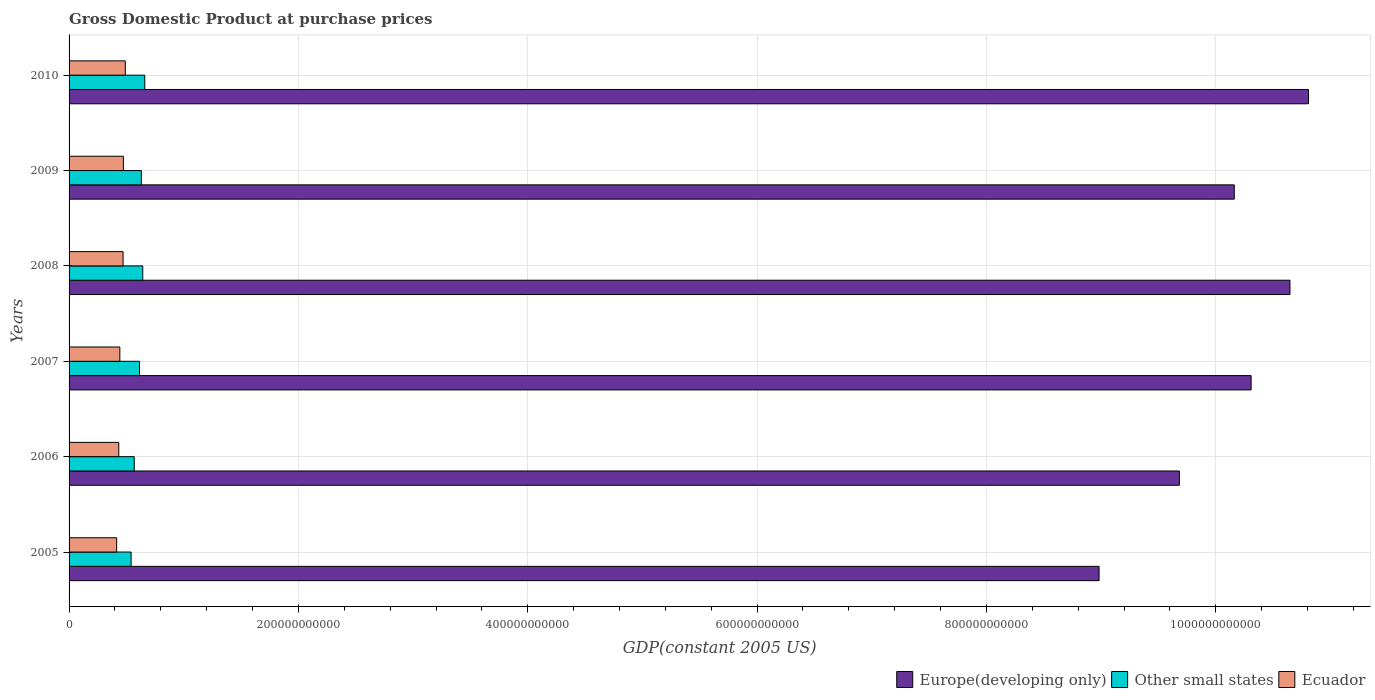How many groups of bars are there?
Your answer should be compact. 6. How many bars are there on the 4th tick from the top?
Keep it short and to the point. 3. How many bars are there on the 1st tick from the bottom?
Ensure brevity in your answer.  3. What is the label of the 2nd group of bars from the top?
Provide a succinct answer. 2009. What is the GDP at purchase prices in Other small states in 2010?
Make the answer very short. 6.60e+1. Across all years, what is the maximum GDP at purchase prices in Other small states?
Provide a short and direct response. 6.60e+1. Across all years, what is the minimum GDP at purchase prices in Other small states?
Your answer should be compact. 5.41e+1. What is the total GDP at purchase prices in Europe(developing only) in the graph?
Your answer should be compact. 6.06e+12. What is the difference between the GDP at purchase prices in Other small states in 2009 and that in 2010?
Your response must be concise. -3.00e+09. What is the difference between the GDP at purchase prices in Europe(developing only) in 2006 and the GDP at purchase prices in Other small states in 2007?
Your response must be concise. 9.07e+11. What is the average GDP at purchase prices in Ecuador per year?
Offer a very short reply. 4.54e+1. In the year 2010, what is the difference between the GDP at purchase prices in Other small states and GDP at purchase prices in Ecuador?
Offer a terse response. 1.70e+1. What is the ratio of the GDP at purchase prices in Europe(developing only) in 2007 to that in 2009?
Give a very brief answer. 1.01. Is the difference between the GDP at purchase prices in Other small states in 2007 and 2008 greater than the difference between the GDP at purchase prices in Ecuador in 2007 and 2008?
Provide a succinct answer. No. What is the difference between the highest and the second highest GDP at purchase prices in Europe(developing only)?
Keep it short and to the point. 1.62e+1. What is the difference between the highest and the lowest GDP at purchase prices in Europe(developing only)?
Provide a succinct answer. 1.83e+11. What does the 3rd bar from the top in 2006 represents?
Offer a terse response. Europe(developing only). What does the 2nd bar from the bottom in 2006 represents?
Provide a short and direct response. Other small states. Is it the case that in every year, the sum of the GDP at purchase prices in Europe(developing only) and GDP at purchase prices in Ecuador is greater than the GDP at purchase prices in Other small states?
Ensure brevity in your answer.  Yes. How many bars are there?
Provide a short and direct response. 18. Are all the bars in the graph horizontal?
Provide a short and direct response. Yes. How many years are there in the graph?
Give a very brief answer. 6. What is the difference between two consecutive major ticks on the X-axis?
Provide a succinct answer. 2.00e+11. Are the values on the major ticks of X-axis written in scientific E-notation?
Provide a short and direct response. No. Does the graph contain grids?
Your answer should be very brief. Yes. How many legend labels are there?
Give a very brief answer. 3. What is the title of the graph?
Make the answer very short. Gross Domestic Product at purchase prices. What is the label or title of the X-axis?
Offer a terse response. GDP(constant 2005 US). What is the label or title of the Y-axis?
Your answer should be very brief. Years. What is the GDP(constant 2005 US) in Europe(developing only) in 2005?
Your answer should be very brief. 8.98e+11. What is the GDP(constant 2005 US) in Other small states in 2005?
Your answer should be compact. 5.41e+1. What is the GDP(constant 2005 US) of Ecuador in 2005?
Give a very brief answer. 4.15e+1. What is the GDP(constant 2005 US) in Europe(developing only) in 2006?
Your response must be concise. 9.68e+11. What is the GDP(constant 2005 US) of Other small states in 2006?
Provide a succinct answer. 5.68e+1. What is the GDP(constant 2005 US) of Ecuador in 2006?
Offer a terse response. 4.33e+1. What is the GDP(constant 2005 US) in Europe(developing only) in 2007?
Offer a very short reply. 1.03e+12. What is the GDP(constant 2005 US) in Other small states in 2007?
Provide a short and direct response. 6.14e+1. What is the GDP(constant 2005 US) in Ecuador in 2007?
Keep it short and to the point. 4.43e+1. What is the GDP(constant 2005 US) of Europe(developing only) in 2008?
Make the answer very short. 1.06e+12. What is the GDP(constant 2005 US) of Other small states in 2008?
Your answer should be compact. 6.43e+1. What is the GDP(constant 2005 US) in Ecuador in 2008?
Your answer should be very brief. 4.71e+1. What is the GDP(constant 2005 US) in Europe(developing only) in 2009?
Offer a very short reply. 1.02e+12. What is the GDP(constant 2005 US) of Other small states in 2009?
Ensure brevity in your answer.  6.30e+1. What is the GDP(constant 2005 US) of Ecuador in 2009?
Ensure brevity in your answer.  4.74e+1. What is the GDP(constant 2005 US) in Europe(developing only) in 2010?
Provide a short and direct response. 1.08e+12. What is the GDP(constant 2005 US) of Other small states in 2010?
Your answer should be very brief. 6.60e+1. What is the GDP(constant 2005 US) in Ecuador in 2010?
Give a very brief answer. 4.90e+1. Across all years, what is the maximum GDP(constant 2005 US) of Europe(developing only)?
Offer a very short reply. 1.08e+12. Across all years, what is the maximum GDP(constant 2005 US) of Other small states?
Offer a terse response. 6.60e+1. Across all years, what is the maximum GDP(constant 2005 US) of Ecuador?
Your answer should be very brief. 4.90e+1. Across all years, what is the minimum GDP(constant 2005 US) of Europe(developing only)?
Your response must be concise. 8.98e+11. Across all years, what is the minimum GDP(constant 2005 US) of Other small states?
Your response must be concise. 5.41e+1. Across all years, what is the minimum GDP(constant 2005 US) in Ecuador?
Provide a short and direct response. 4.15e+1. What is the total GDP(constant 2005 US) in Europe(developing only) in the graph?
Provide a succinct answer. 6.06e+12. What is the total GDP(constant 2005 US) of Other small states in the graph?
Your response must be concise. 3.66e+11. What is the total GDP(constant 2005 US) of Ecuador in the graph?
Ensure brevity in your answer.  2.73e+11. What is the difference between the GDP(constant 2005 US) of Europe(developing only) in 2005 and that in 2006?
Make the answer very short. -7.00e+1. What is the difference between the GDP(constant 2005 US) of Other small states in 2005 and that in 2006?
Provide a short and direct response. -2.72e+09. What is the difference between the GDP(constant 2005 US) in Ecuador in 2005 and that in 2006?
Offer a terse response. -1.83e+09. What is the difference between the GDP(constant 2005 US) in Europe(developing only) in 2005 and that in 2007?
Give a very brief answer. -1.33e+11. What is the difference between the GDP(constant 2005 US) in Other small states in 2005 and that in 2007?
Your answer should be compact. -7.31e+09. What is the difference between the GDP(constant 2005 US) in Ecuador in 2005 and that in 2007?
Offer a terse response. -2.78e+09. What is the difference between the GDP(constant 2005 US) in Europe(developing only) in 2005 and that in 2008?
Your response must be concise. -1.66e+11. What is the difference between the GDP(constant 2005 US) of Other small states in 2005 and that in 2008?
Your answer should be compact. -1.02e+1. What is the difference between the GDP(constant 2005 US) of Ecuador in 2005 and that in 2008?
Make the answer very short. -5.59e+09. What is the difference between the GDP(constant 2005 US) in Europe(developing only) in 2005 and that in 2009?
Your answer should be compact. -1.18e+11. What is the difference between the GDP(constant 2005 US) of Other small states in 2005 and that in 2009?
Give a very brief answer. -8.92e+09. What is the difference between the GDP(constant 2005 US) in Ecuador in 2005 and that in 2009?
Your response must be concise. -5.86e+09. What is the difference between the GDP(constant 2005 US) of Europe(developing only) in 2005 and that in 2010?
Your answer should be very brief. -1.83e+11. What is the difference between the GDP(constant 2005 US) of Other small states in 2005 and that in 2010?
Your answer should be very brief. -1.19e+1. What is the difference between the GDP(constant 2005 US) of Ecuador in 2005 and that in 2010?
Your answer should be very brief. -7.53e+09. What is the difference between the GDP(constant 2005 US) of Europe(developing only) in 2006 and that in 2007?
Offer a very short reply. -6.26e+1. What is the difference between the GDP(constant 2005 US) of Other small states in 2006 and that in 2007?
Keep it short and to the point. -4.60e+09. What is the difference between the GDP(constant 2005 US) of Ecuador in 2006 and that in 2007?
Your response must be concise. -9.49e+08. What is the difference between the GDP(constant 2005 US) in Europe(developing only) in 2006 and that in 2008?
Your answer should be very brief. -9.64e+1. What is the difference between the GDP(constant 2005 US) of Other small states in 2006 and that in 2008?
Ensure brevity in your answer.  -7.43e+09. What is the difference between the GDP(constant 2005 US) of Ecuador in 2006 and that in 2008?
Provide a short and direct response. -3.76e+09. What is the difference between the GDP(constant 2005 US) of Europe(developing only) in 2006 and that in 2009?
Offer a terse response. -4.79e+1. What is the difference between the GDP(constant 2005 US) of Other small states in 2006 and that in 2009?
Offer a very short reply. -6.20e+09. What is the difference between the GDP(constant 2005 US) in Ecuador in 2006 and that in 2009?
Your response must be concise. -4.03e+09. What is the difference between the GDP(constant 2005 US) in Europe(developing only) in 2006 and that in 2010?
Provide a succinct answer. -1.13e+11. What is the difference between the GDP(constant 2005 US) in Other small states in 2006 and that in 2010?
Provide a short and direct response. -9.20e+09. What is the difference between the GDP(constant 2005 US) of Ecuador in 2006 and that in 2010?
Make the answer very short. -5.70e+09. What is the difference between the GDP(constant 2005 US) of Europe(developing only) in 2007 and that in 2008?
Provide a short and direct response. -3.39e+1. What is the difference between the GDP(constant 2005 US) of Other small states in 2007 and that in 2008?
Keep it short and to the point. -2.84e+09. What is the difference between the GDP(constant 2005 US) in Ecuador in 2007 and that in 2008?
Give a very brief answer. -2.82e+09. What is the difference between the GDP(constant 2005 US) of Europe(developing only) in 2007 and that in 2009?
Ensure brevity in your answer.  1.47e+1. What is the difference between the GDP(constant 2005 US) of Other small states in 2007 and that in 2009?
Offer a terse response. -1.60e+09. What is the difference between the GDP(constant 2005 US) in Ecuador in 2007 and that in 2009?
Your response must be concise. -3.08e+09. What is the difference between the GDP(constant 2005 US) in Europe(developing only) in 2007 and that in 2010?
Provide a short and direct response. -5.01e+1. What is the difference between the GDP(constant 2005 US) in Other small states in 2007 and that in 2010?
Offer a terse response. -4.60e+09. What is the difference between the GDP(constant 2005 US) of Ecuador in 2007 and that in 2010?
Keep it short and to the point. -4.75e+09. What is the difference between the GDP(constant 2005 US) of Europe(developing only) in 2008 and that in 2009?
Provide a succinct answer. 4.86e+1. What is the difference between the GDP(constant 2005 US) of Other small states in 2008 and that in 2009?
Ensure brevity in your answer.  1.23e+09. What is the difference between the GDP(constant 2005 US) in Ecuador in 2008 and that in 2009?
Provide a succinct answer. -2.67e+08. What is the difference between the GDP(constant 2005 US) of Europe(developing only) in 2008 and that in 2010?
Give a very brief answer. -1.62e+1. What is the difference between the GDP(constant 2005 US) in Other small states in 2008 and that in 2010?
Offer a terse response. -1.76e+09. What is the difference between the GDP(constant 2005 US) in Ecuador in 2008 and that in 2010?
Offer a very short reply. -1.94e+09. What is the difference between the GDP(constant 2005 US) in Europe(developing only) in 2009 and that in 2010?
Your response must be concise. -6.47e+1. What is the difference between the GDP(constant 2005 US) of Other small states in 2009 and that in 2010?
Your answer should be very brief. -3.00e+09. What is the difference between the GDP(constant 2005 US) in Ecuador in 2009 and that in 2010?
Make the answer very short. -1.67e+09. What is the difference between the GDP(constant 2005 US) in Europe(developing only) in 2005 and the GDP(constant 2005 US) in Other small states in 2006?
Give a very brief answer. 8.41e+11. What is the difference between the GDP(constant 2005 US) of Europe(developing only) in 2005 and the GDP(constant 2005 US) of Ecuador in 2006?
Give a very brief answer. 8.55e+11. What is the difference between the GDP(constant 2005 US) in Other small states in 2005 and the GDP(constant 2005 US) in Ecuador in 2006?
Give a very brief answer. 1.08e+1. What is the difference between the GDP(constant 2005 US) in Europe(developing only) in 2005 and the GDP(constant 2005 US) in Other small states in 2007?
Provide a short and direct response. 8.37e+11. What is the difference between the GDP(constant 2005 US) of Europe(developing only) in 2005 and the GDP(constant 2005 US) of Ecuador in 2007?
Provide a succinct answer. 8.54e+11. What is the difference between the GDP(constant 2005 US) of Other small states in 2005 and the GDP(constant 2005 US) of Ecuador in 2007?
Your answer should be very brief. 9.83e+09. What is the difference between the GDP(constant 2005 US) in Europe(developing only) in 2005 and the GDP(constant 2005 US) in Other small states in 2008?
Your answer should be compact. 8.34e+11. What is the difference between the GDP(constant 2005 US) in Europe(developing only) in 2005 and the GDP(constant 2005 US) in Ecuador in 2008?
Make the answer very short. 8.51e+11. What is the difference between the GDP(constant 2005 US) of Other small states in 2005 and the GDP(constant 2005 US) of Ecuador in 2008?
Offer a terse response. 7.01e+09. What is the difference between the GDP(constant 2005 US) in Europe(developing only) in 2005 and the GDP(constant 2005 US) in Other small states in 2009?
Your answer should be very brief. 8.35e+11. What is the difference between the GDP(constant 2005 US) of Europe(developing only) in 2005 and the GDP(constant 2005 US) of Ecuador in 2009?
Offer a very short reply. 8.51e+11. What is the difference between the GDP(constant 2005 US) of Other small states in 2005 and the GDP(constant 2005 US) of Ecuador in 2009?
Your answer should be very brief. 6.74e+09. What is the difference between the GDP(constant 2005 US) in Europe(developing only) in 2005 and the GDP(constant 2005 US) in Other small states in 2010?
Offer a terse response. 8.32e+11. What is the difference between the GDP(constant 2005 US) in Europe(developing only) in 2005 and the GDP(constant 2005 US) in Ecuador in 2010?
Your answer should be compact. 8.49e+11. What is the difference between the GDP(constant 2005 US) in Other small states in 2005 and the GDP(constant 2005 US) in Ecuador in 2010?
Ensure brevity in your answer.  5.07e+09. What is the difference between the GDP(constant 2005 US) in Europe(developing only) in 2006 and the GDP(constant 2005 US) in Other small states in 2007?
Keep it short and to the point. 9.07e+11. What is the difference between the GDP(constant 2005 US) in Europe(developing only) in 2006 and the GDP(constant 2005 US) in Ecuador in 2007?
Ensure brevity in your answer.  9.24e+11. What is the difference between the GDP(constant 2005 US) of Other small states in 2006 and the GDP(constant 2005 US) of Ecuador in 2007?
Make the answer very short. 1.25e+1. What is the difference between the GDP(constant 2005 US) in Europe(developing only) in 2006 and the GDP(constant 2005 US) in Other small states in 2008?
Make the answer very short. 9.04e+11. What is the difference between the GDP(constant 2005 US) of Europe(developing only) in 2006 and the GDP(constant 2005 US) of Ecuador in 2008?
Your answer should be compact. 9.21e+11. What is the difference between the GDP(constant 2005 US) of Other small states in 2006 and the GDP(constant 2005 US) of Ecuador in 2008?
Offer a terse response. 9.73e+09. What is the difference between the GDP(constant 2005 US) in Europe(developing only) in 2006 and the GDP(constant 2005 US) in Other small states in 2009?
Give a very brief answer. 9.05e+11. What is the difference between the GDP(constant 2005 US) in Europe(developing only) in 2006 and the GDP(constant 2005 US) in Ecuador in 2009?
Provide a short and direct response. 9.21e+11. What is the difference between the GDP(constant 2005 US) in Other small states in 2006 and the GDP(constant 2005 US) in Ecuador in 2009?
Ensure brevity in your answer.  9.46e+09. What is the difference between the GDP(constant 2005 US) in Europe(developing only) in 2006 and the GDP(constant 2005 US) in Other small states in 2010?
Offer a terse response. 9.02e+11. What is the difference between the GDP(constant 2005 US) in Europe(developing only) in 2006 and the GDP(constant 2005 US) in Ecuador in 2010?
Ensure brevity in your answer.  9.19e+11. What is the difference between the GDP(constant 2005 US) of Other small states in 2006 and the GDP(constant 2005 US) of Ecuador in 2010?
Your answer should be compact. 7.79e+09. What is the difference between the GDP(constant 2005 US) in Europe(developing only) in 2007 and the GDP(constant 2005 US) in Other small states in 2008?
Offer a terse response. 9.67e+11. What is the difference between the GDP(constant 2005 US) in Europe(developing only) in 2007 and the GDP(constant 2005 US) in Ecuador in 2008?
Your response must be concise. 9.84e+11. What is the difference between the GDP(constant 2005 US) in Other small states in 2007 and the GDP(constant 2005 US) in Ecuador in 2008?
Keep it short and to the point. 1.43e+1. What is the difference between the GDP(constant 2005 US) in Europe(developing only) in 2007 and the GDP(constant 2005 US) in Other small states in 2009?
Your response must be concise. 9.68e+11. What is the difference between the GDP(constant 2005 US) of Europe(developing only) in 2007 and the GDP(constant 2005 US) of Ecuador in 2009?
Your answer should be compact. 9.83e+11. What is the difference between the GDP(constant 2005 US) in Other small states in 2007 and the GDP(constant 2005 US) in Ecuador in 2009?
Your answer should be compact. 1.41e+1. What is the difference between the GDP(constant 2005 US) of Europe(developing only) in 2007 and the GDP(constant 2005 US) of Other small states in 2010?
Keep it short and to the point. 9.65e+11. What is the difference between the GDP(constant 2005 US) of Europe(developing only) in 2007 and the GDP(constant 2005 US) of Ecuador in 2010?
Give a very brief answer. 9.82e+11. What is the difference between the GDP(constant 2005 US) of Other small states in 2007 and the GDP(constant 2005 US) of Ecuador in 2010?
Your answer should be compact. 1.24e+1. What is the difference between the GDP(constant 2005 US) in Europe(developing only) in 2008 and the GDP(constant 2005 US) in Other small states in 2009?
Ensure brevity in your answer.  1.00e+12. What is the difference between the GDP(constant 2005 US) in Europe(developing only) in 2008 and the GDP(constant 2005 US) in Ecuador in 2009?
Offer a terse response. 1.02e+12. What is the difference between the GDP(constant 2005 US) of Other small states in 2008 and the GDP(constant 2005 US) of Ecuador in 2009?
Your answer should be very brief. 1.69e+1. What is the difference between the GDP(constant 2005 US) in Europe(developing only) in 2008 and the GDP(constant 2005 US) in Other small states in 2010?
Keep it short and to the point. 9.99e+11. What is the difference between the GDP(constant 2005 US) in Europe(developing only) in 2008 and the GDP(constant 2005 US) in Ecuador in 2010?
Make the answer very short. 1.02e+12. What is the difference between the GDP(constant 2005 US) in Other small states in 2008 and the GDP(constant 2005 US) in Ecuador in 2010?
Your answer should be compact. 1.52e+1. What is the difference between the GDP(constant 2005 US) in Europe(developing only) in 2009 and the GDP(constant 2005 US) in Other small states in 2010?
Offer a very short reply. 9.50e+11. What is the difference between the GDP(constant 2005 US) of Europe(developing only) in 2009 and the GDP(constant 2005 US) of Ecuador in 2010?
Offer a very short reply. 9.67e+11. What is the difference between the GDP(constant 2005 US) of Other small states in 2009 and the GDP(constant 2005 US) of Ecuador in 2010?
Provide a succinct answer. 1.40e+1. What is the average GDP(constant 2005 US) of Europe(developing only) per year?
Provide a succinct answer. 1.01e+12. What is the average GDP(constant 2005 US) of Other small states per year?
Provide a succinct answer. 6.09e+1. What is the average GDP(constant 2005 US) in Ecuador per year?
Give a very brief answer. 4.54e+1. In the year 2005, what is the difference between the GDP(constant 2005 US) of Europe(developing only) and GDP(constant 2005 US) of Other small states?
Your answer should be very brief. 8.44e+11. In the year 2005, what is the difference between the GDP(constant 2005 US) in Europe(developing only) and GDP(constant 2005 US) in Ecuador?
Your response must be concise. 8.57e+11. In the year 2005, what is the difference between the GDP(constant 2005 US) in Other small states and GDP(constant 2005 US) in Ecuador?
Offer a very short reply. 1.26e+1. In the year 2006, what is the difference between the GDP(constant 2005 US) of Europe(developing only) and GDP(constant 2005 US) of Other small states?
Give a very brief answer. 9.11e+11. In the year 2006, what is the difference between the GDP(constant 2005 US) of Europe(developing only) and GDP(constant 2005 US) of Ecuador?
Make the answer very short. 9.25e+11. In the year 2006, what is the difference between the GDP(constant 2005 US) in Other small states and GDP(constant 2005 US) in Ecuador?
Make the answer very short. 1.35e+1. In the year 2007, what is the difference between the GDP(constant 2005 US) in Europe(developing only) and GDP(constant 2005 US) in Other small states?
Ensure brevity in your answer.  9.69e+11. In the year 2007, what is the difference between the GDP(constant 2005 US) in Europe(developing only) and GDP(constant 2005 US) in Ecuador?
Provide a short and direct response. 9.87e+11. In the year 2007, what is the difference between the GDP(constant 2005 US) in Other small states and GDP(constant 2005 US) in Ecuador?
Provide a short and direct response. 1.71e+1. In the year 2008, what is the difference between the GDP(constant 2005 US) of Europe(developing only) and GDP(constant 2005 US) of Other small states?
Make the answer very short. 1.00e+12. In the year 2008, what is the difference between the GDP(constant 2005 US) in Europe(developing only) and GDP(constant 2005 US) in Ecuador?
Your response must be concise. 1.02e+12. In the year 2008, what is the difference between the GDP(constant 2005 US) of Other small states and GDP(constant 2005 US) of Ecuador?
Offer a terse response. 1.72e+1. In the year 2009, what is the difference between the GDP(constant 2005 US) in Europe(developing only) and GDP(constant 2005 US) in Other small states?
Your answer should be compact. 9.53e+11. In the year 2009, what is the difference between the GDP(constant 2005 US) of Europe(developing only) and GDP(constant 2005 US) of Ecuador?
Provide a succinct answer. 9.69e+11. In the year 2009, what is the difference between the GDP(constant 2005 US) of Other small states and GDP(constant 2005 US) of Ecuador?
Ensure brevity in your answer.  1.57e+1. In the year 2010, what is the difference between the GDP(constant 2005 US) in Europe(developing only) and GDP(constant 2005 US) in Other small states?
Offer a terse response. 1.01e+12. In the year 2010, what is the difference between the GDP(constant 2005 US) of Europe(developing only) and GDP(constant 2005 US) of Ecuador?
Keep it short and to the point. 1.03e+12. In the year 2010, what is the difference between the GDP(constant 2005 US) in Other small states and GDP(constant 2005 US) in Ecuador?
Your response must be concise. 1.70e+1. What is the ratio of the GDP(constant 2005 US) of Europe(developing only) in 2005 to that in 2006?
Offer a terse response. 0.93. What is the ratio of the GDP(constant 2005 US) of Other small states in 2005 to that in 2006?
Give a very brief answer. 0.95. What is the ratio of the GDP(constant 2005 US) of Ecuador in 2005 to that in 2006?
Ensure brevity in your answer.  0.96. What is the ratio of the GDP(constant 2005 US) in Europe(developing only) in 2005 to that in 2007?
Give a very brief answer. 0.87. What is the ratio of the GDP(constant 2005 US) of Other small states in 2005 to that in 2007?
Make the answer very short. 0.88. What is the ratio of the GDP(constant 2005 US) of Ecuador in 2005 to that in 2007?
Make the answer very short. 0.94. What is the ratio of the GDP(constant 2005 US) in Europe(developing only) in 2005 to that in 2008?
Offer a terse response. 0.84. What is the ratio of the GDP(constant 2005 US) in Other small states in 2005 to that in 2008?
Keep it short and to the point. 0.84. What is the ratio of the GDP(constant 2005 US) in Ecuador in 2005 to that in 2008?
Ensure brevity in your answer.  0.88. What is the ratio of the GDP(constant 2005 US) in Europe(developing only) in 2005 to that in 2009?
Your response must be concise. 0.88. What is the ratio of the GDP(constant 2005 US) of Other small states in 2005 to that in 2009?
Give a very brief answer. 0.86. What is the ratio of the GDP(constant 2005 US) in Ecuador in 2005 to that in 2009?
Your response must be concise. 0.88. What is the ratio of the GDP(constant 2005 US) in Europe(developing only) in 2005 to that in 2010?
Make the answer very short. 0.83. What is the ratio of the GDP(constant 2005 US) in Other small states in 2005 to that in 2010?
Your answer should be compact. 0.82. What is the ratio of the GDP(constant 2005 US) in Ecuador in 2005 to that in 2010?
Your response must be concise. 0.85. What is the ratio of the GDP(constant 2005 US) in Europe(developing only) in 2006 to that in 2007?
Give a very brief answer. 0.94. What is the ratio of the GDP(constant 2005 US) in Other small states in 2006 to that in 2007?
Provide a succinct answer. 0.93. What is the ratio of the GDP(constant 2005 US) of Ecuador in 2006 to that in 2007?
Your answer should be compact. 0.98. What is the ratio of the GDP(constant 2005 US) of Europe(developing only) in 2006 to that in 2008?
Keep it short and to the point. 0.91. What is the ratio of the GDP(constant 2005 US) of Other small states in 2006 to that in 2008?
Provide a short and direct response. 0.88. What is the ratio of the GDP(constant 2005 US) in Ecuador in 2006 to that in 2008?
Your answer should be very brief. 0.92. What is the ratio of the GDP(constant 2005 US) of Europe(developing only) in 2006 to that in 2009?
Your answer should be compact. 0.95. What is the ratio of the GDP(constant 2005 US) in Other small states in 2006 to that in 2009?
Your response must be concise. 0.9. What is the ratio of the GDP(constant 2005 US) of Ecuador in 2006 to that in 2009?
Your answer should be compact. 0.91. What is the ratio of the GDP(constant 2005 US) in Europe(developing only) in 2006 to that in 2010?
Ensure brevity in your answer.  0.9. What is the ratio of the GDP(constant 2005 US) in Other small states in 2006 to that in 2010?
Your answer should be compact. 0.86. What is the ratio of the GDP(constant 2005 US) in Ecuador in 2006 to that in 2010?
Make the answer very short. 0.88. What is the ratio of the GDP(constant 2005 US) in Europe(developing only) in 2007 to that in 2008?
Give a very brief answer. 0.97. What is the ratio of the GDP(constant 2005 US) in Other small states in 2007 to that in 2008?
Keep it short and to the point. 0.96. What is the ratio of the GDP(constant 2005 US) in Ecuador in 2007 to that in 2008?
Your answer should be very brief. 0.94. What is the ratio of the GDP(constant 2005 US) in Europe(developing only) in 2007 to that in 2009?
Keep it short and to the point. 1.01. What is the ratio of the GDP(constant 2005 US) in Other small states in 2007 to that in 2009?
Provide a short and direct response. 0.97. What is the ratio of the GDP(constant 2005 US) in Ecuador in 2007 to that in 2009?
Offer a terse response. 0.93. What is the ratio of the GDP(constant 2005 US) in Europe(developing only) in 2007 to that in 2010?
Your answer should be compact. 0.95. What is the ratio of the GDP(constant 2005 US) of Other small states in 2007 to that in 2010?
Offer a terse response. 0.93. What is the ratio of the GDP(constant 2005 US) in Ecuador in 2007 to that in 2010?
Your answer should be compact. 0.9. What is the ratio of the GDP(constant 2005 US) in Europe(developing only) in 2008 to that in 2009?
Provide a short and direct response. 1.05. What is the ratio of the GDP(constant 2005 US) in Other small states in 2008 to that in 2009?
Give a very brief answer. 1.02. What is the ratio of the GDP(constant 2005 US) in Europe(developing only) in 2008 to that in 2010?
Offer a terse response. 0.98. What is the ratio of the GDP(constant 2005 US) of Other small states in 2008 to that in 2010?
Your answer should be very brief. 0.97. What is the ratio of the GDP(constant 2005 US) in Ecuador in 2008 to that in 2010?
Give a very brief answer. 0.96. What is the ratio of the GDP(constant 2005 US) in Europe(developing only) in 2009 to that in 2010?
Offer a very short reply. 0.94. What is the ratio of the GDP(constant 2005 US) of Other small states in 2009 to that in 2010?
Your response must be concise. 0.95. What is the ratio of the GDP(constant 2005 US) in Ecuador in 2009 to that in 2010?
Offer a very short reply. 0.97. What is the difference between the highest and the second highest GDP(constant 2005 US) of Europe(developing only)?
Your response must be concise. 1.62e+1. What is the difference between the highest and the second highest GDP(constant 2005 US) in Other small states?
Give a very brief answer. 1.76e+09. What is the difference between the highest and the second highest GDP(constant 2005 US) in Ecuador?
Give a very brief answer. 1.67e+09. What is the difference between the highest and the lowest GDP(constant 2005 US) in Europe(developing only)?
Make the answer very short. 1.83e+11. What is the difference between the highest and the lowest GDP(constant 2005 US) in Other small states?
Make the answer very short. 1.19e+1. What is the difference between the highest and the lowest GDP(constant 2005 US) in Ecuador?
Offer a very short reply. 7.53e+09. 